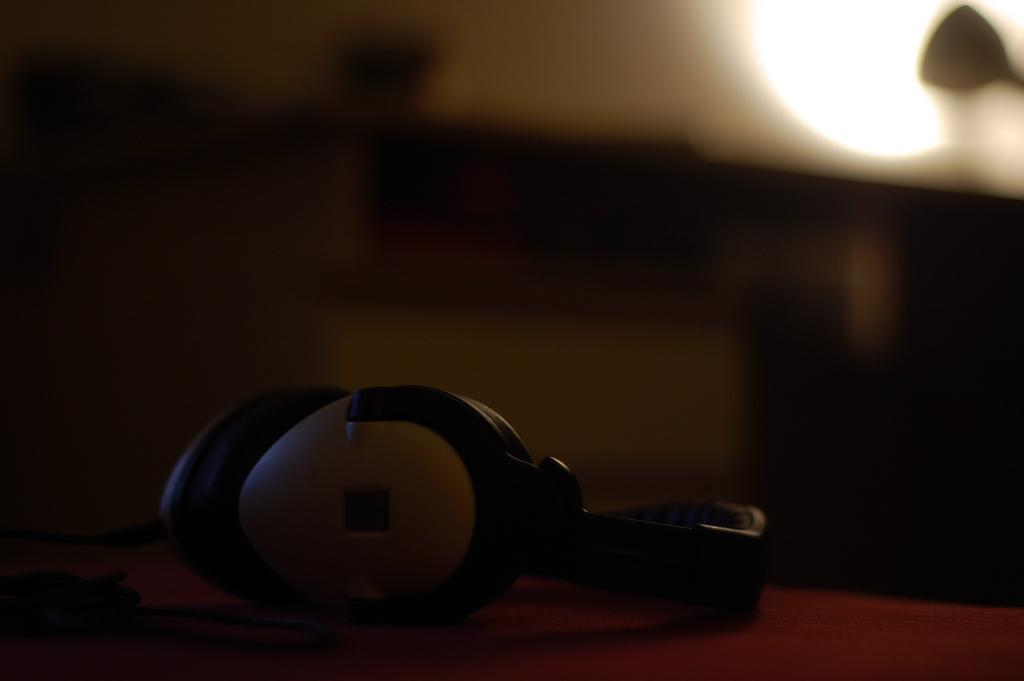What can be seen on the surface in the image? There are headphones on a surface in the image. Can you describe the background of the image? The background of the image is blurred. What type of bait is being used to catch fish in the image? There is no mention of fish or bait in the image; it only features headphones on a surface. 